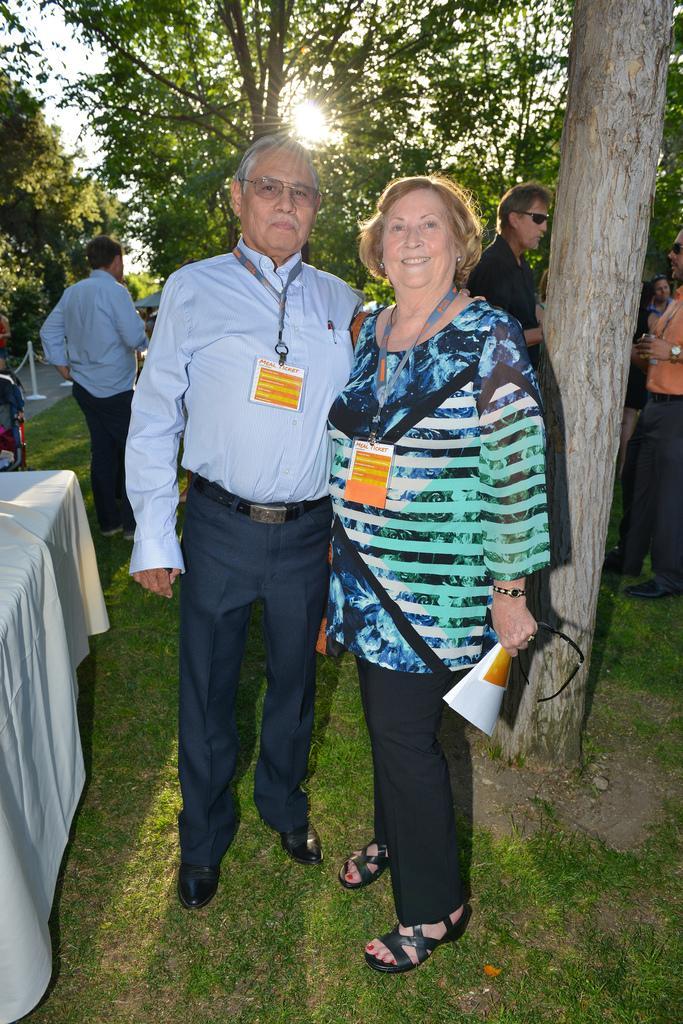Describe this image in one or two sentences. In a garden there are group of people standing and in the front there is a man and a woman standing one beside another and posing for the photograph,they both are wearing an id cards. Beside them there is a table and in the background there are many trees and there is a bright sunshine falling through the trees. 